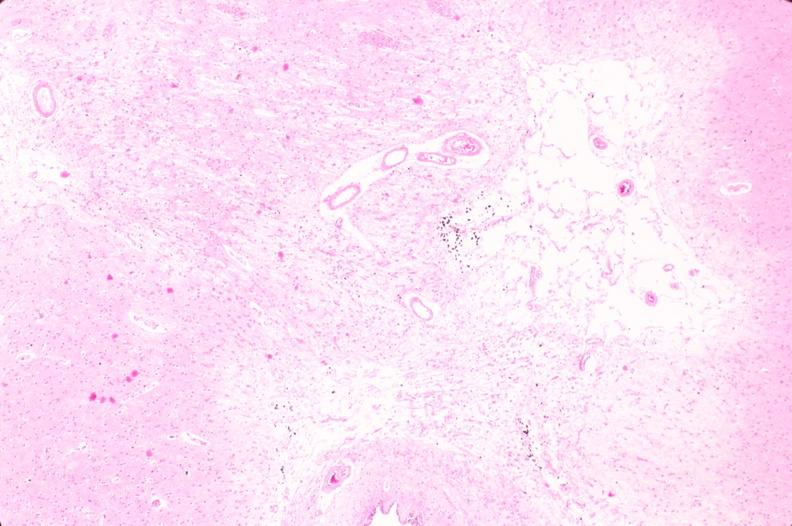does this image show brain, infarct due to ruptured saccular aneurysm and thrombosis of right middle cerebral artery?
Answer the question using a single word or phrase. Yes 